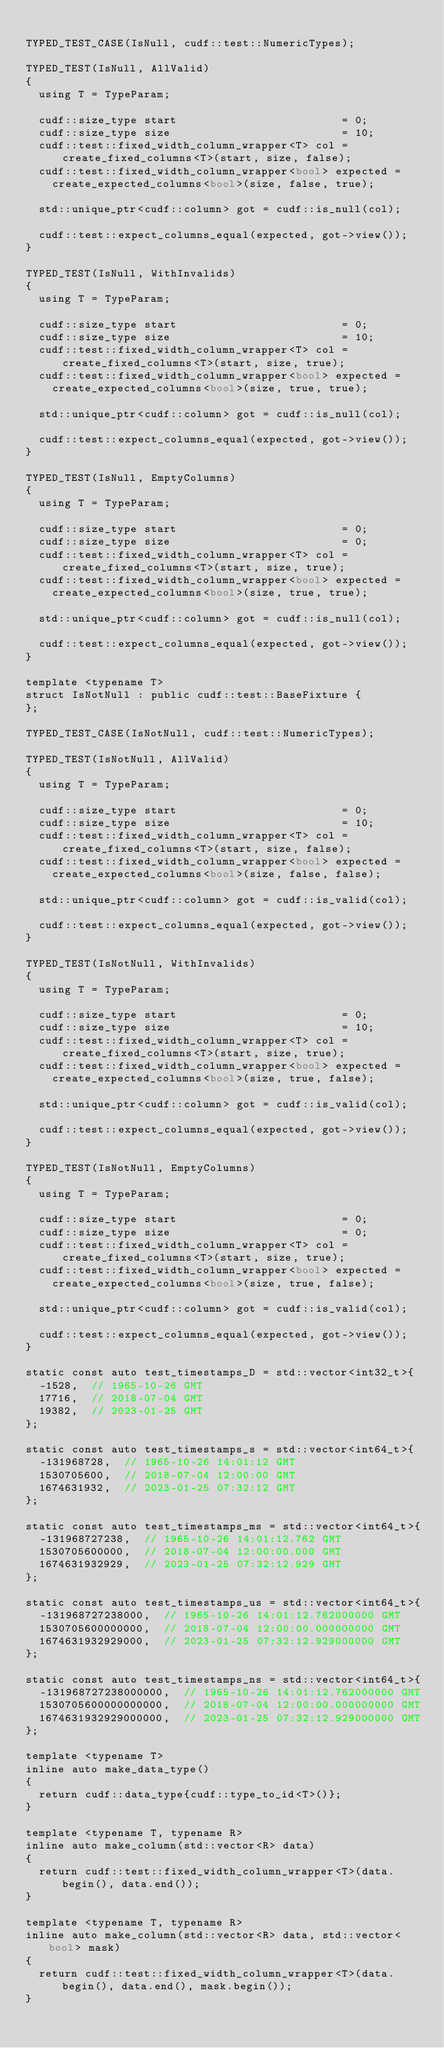<code> <loc_0><loc_0><loc_500><loc_500><_Cuda_>
TYPED_TEST_CASE(IsNull, cudf::test::NumericTypes);

TYPED_TEST(IsNull, AllValid)
{
  using T = TypeParam;

  cudf::size_type start                         = 0;
  cudf::size_type size                          = 10;
  cudf::test::fixed_width_column_wrapper<T> col = create_fixed_columns<T>(start, size, false);
  cudf::test::fixed_width_column_wrapper<bool> expected =
    create_expected_columns<bool>(size, false, true);

  std::unique_ptr<cudf::column> got = cudf::is_null(col);

  cudf::test::expect_columns_equal(expected, got->view());
}

TYPED_TEST(IsNull, WithInvalids)
{
  using T = TypeParam;

  cudf::size_type start                         = 0;
  cudf::size_type size                          = 10;
  cudf::test::fixed_width_column_wrapper<T> col = create_fixed_columns<T>(start, size, true);
  cudf::test::fixed_width_column_wrapper<bool> expected =
    create_expected_columns<bool>(size, true, true);

  std::unique_ptr<cudf::column> got = cudf::is_null(col);

  cudf::test::expect_columns_equal(expected, got->view());
}

TYPED_TEST(IsNull, EmptyColumns)
{
  using T = TypeParam;

  cudf::size_type start                         = 0;
  cudf::size_type size                          = 0;
  cudf::test::fixed_width_column_wrapper<T> col = create_fixed_columns<T>(start, size, true);
  cudf::test::fixed_width_column_wrapper<bool> expected =
    create_expected_columns<bool>(size, true, true);

  std::unique_ptr<cudf::column> got = cudf::is_null(col);

  cudf::test::expect_columns_equal(expected, got->view());
}

template <typename T>
struct IsNotNull : public cudf::test::BaseFixture {
};

TYPED_TEST_CASE(IsNotNull, cudf::test::NumericTypes);

TYPED_TEST(IsNotNull, AllValid)
{
  using T = TypeParam;

  cudf::size_type start                         = 0;
  cudf::size_type size                          = 10;
  cudf::test::fixed_width_column_wrapper<T> col = create_fixed_columns<T>(start, size, false);
  cudf::test::fixed_width_column_wrapper<bool> expected =
    create_expected_columns<bool>(size, false, false);

  std::unique_ptr<cudf::column> got = cudf::is_valid(col);

  cudf::test::expect_columns_equal(expected, got->view());
}

TYPED_TEST(IsNotNull, WithInvalids)
{
  using T = TypeParam;

  cudf::size_type start                         = 0;
  cudf::size_type size                          = 10;
  cudf::test::fixed_width_column_wrapper<T> col = create_fixed_columns<T>(start, size, true);
  cudf::test::fixed_width_column_wrapper<bool> expected =
    create_expected_columns<bool>(size, true, false);

  std::unique_ptr<cudf::column> got = cudf::is_valid(col);

  cudf::test::expect_columns_equal(expected, got->view());
}

TYPED_TEST(IsNotNull, EmptyColumns)
{
  using T = TypeParam;

  cudf::size_type start                         = 0;
  cudf::size_type size                          = 0;
  cudf::test::fixed_width_column_wrapper<T> col = create_fixed_columns<T>(start, size, true);
  cudf::test::fixed_width_column_wrapper<bool> expected =
    create_expected_columns<bool>(size, true, false);

  std::unique_ptr<cudf::column> got = cudf::is_valid(col);

  cudf::test::expect_columns_equal(expected, got->view());
}

static const auto test_timestamps_D = std::vector<int32_t>{
  -1528,  // 1965-10-26 GMT
  17716,  // 2018-07-04 GMT
  19382,  // 2023-01-25 GMT
};

static const auto test_timestamps_s = std::vector<int64_t>{
  -131968728,  // 1965-10-26 14:01:12 GMT
  1530705600,  // 2018-07-04 12:00:00 GMT
  1674631932,  // 2023-01-25 07:32:12 GMT
};

static const auto test_timestamps_ms = std::vector<int64_t>{
  -131968727238,  // 1965-10-26 14:01:12.762 GMT
  1530705600000,  // 2018-07-04 12:00:00.000 GMT
  1674631932929,  // 2023-01-25 07:32:12.929 GMT
};

static const auto test_timestamps_us = std::vector<int64_t>{
  -131968727238000,  // 1965-10-26 14:01:12.762000000 GMT
  1530705600000000,  // 2018-07-04 12:00:00.000000000 GMT
  1674631932929000,  // 2023-01-25 07:32:12.929000000 GMT
};

static const auto test_timestamps_ns = std::vector<int64_t>{
  -131968727238000000,  // 1965-10-26 14:01:12.762000000 GMT
  1530705600000000000,  // 2018-07-04 12:00:00.000000000 GMT
  1674631932929000000,  // 2023-01-25 07:32:12.929000000 GMT
};

template <typename T>
inline auto make_data_type()
{
  return cudf::data_type{cudf::type_to_id<T>()};
}

template <typename T, typename R>
inline auto make_column(std::vector<R> data)
{
  return cudf::test::fixed_width_column_wrapper<T>(data.begin(), data.end());
}

template <typename T, typename R>
inline auto make_column(std::vector<R> data, std::vector<bool> mask)
{
  return cudf::test::fixed_width_column_wrapper<T>(data.begin(), data.end(), mask.begin());
}
</code> 